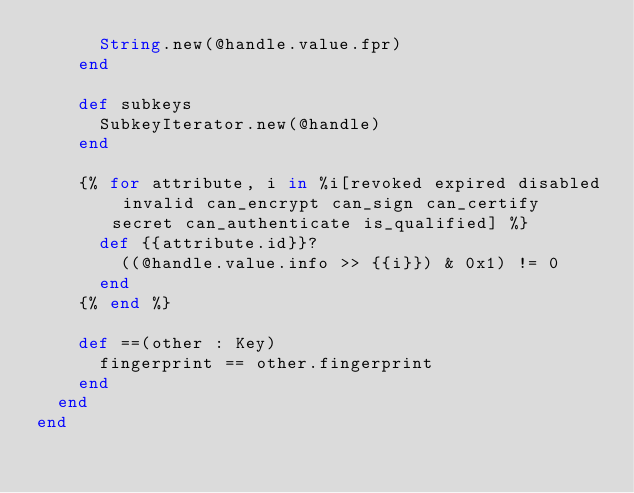Convert code to text. <code><loc_0><loc_0><loc_500><loc_500><_Crystal_>      String.new(@handle.value.fpr)
    end

    def subkeys
      SubkeyIterator.new(@handle)
    end

    {% for attribute, i in %i[revoked expired disabled invalid can_encrypt can_sign can_certify secret can_authenticate is_qualified] %}
      def {{attribute.id}}?
        ((@handle.value.info >> {{i}}) & 0x1) != 0
      end
    {% end %}

    def ==(other : Key)
      fingerprint == other.fingerprint
    end
  end
end
</code> 